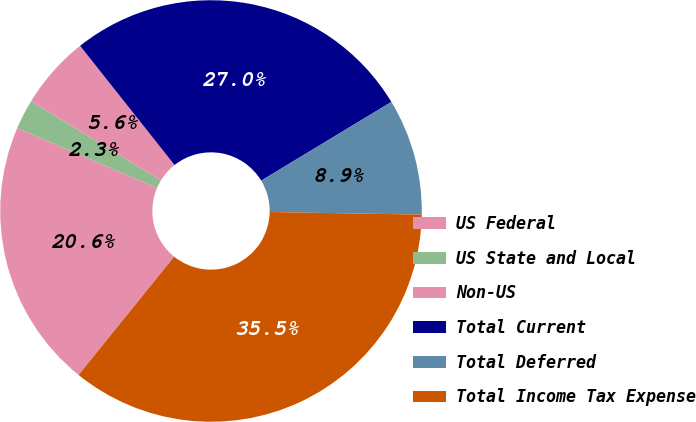Convert chart to OTSL. <chart><loc_0><loc_0><loc_500><loc_500><pie_chart><fcel>US Federal<fcel>US State and Local<fcel>Non-US<fcel>Total Current<fcel>Total Deferred<fcel>Total Income Tax Expense<nl><fcel>20.63%<fcel>2.28%<fcel>5.61%<fcel>27.01%<fcel>8.93%<fcel>35.54%<nl></chart> 